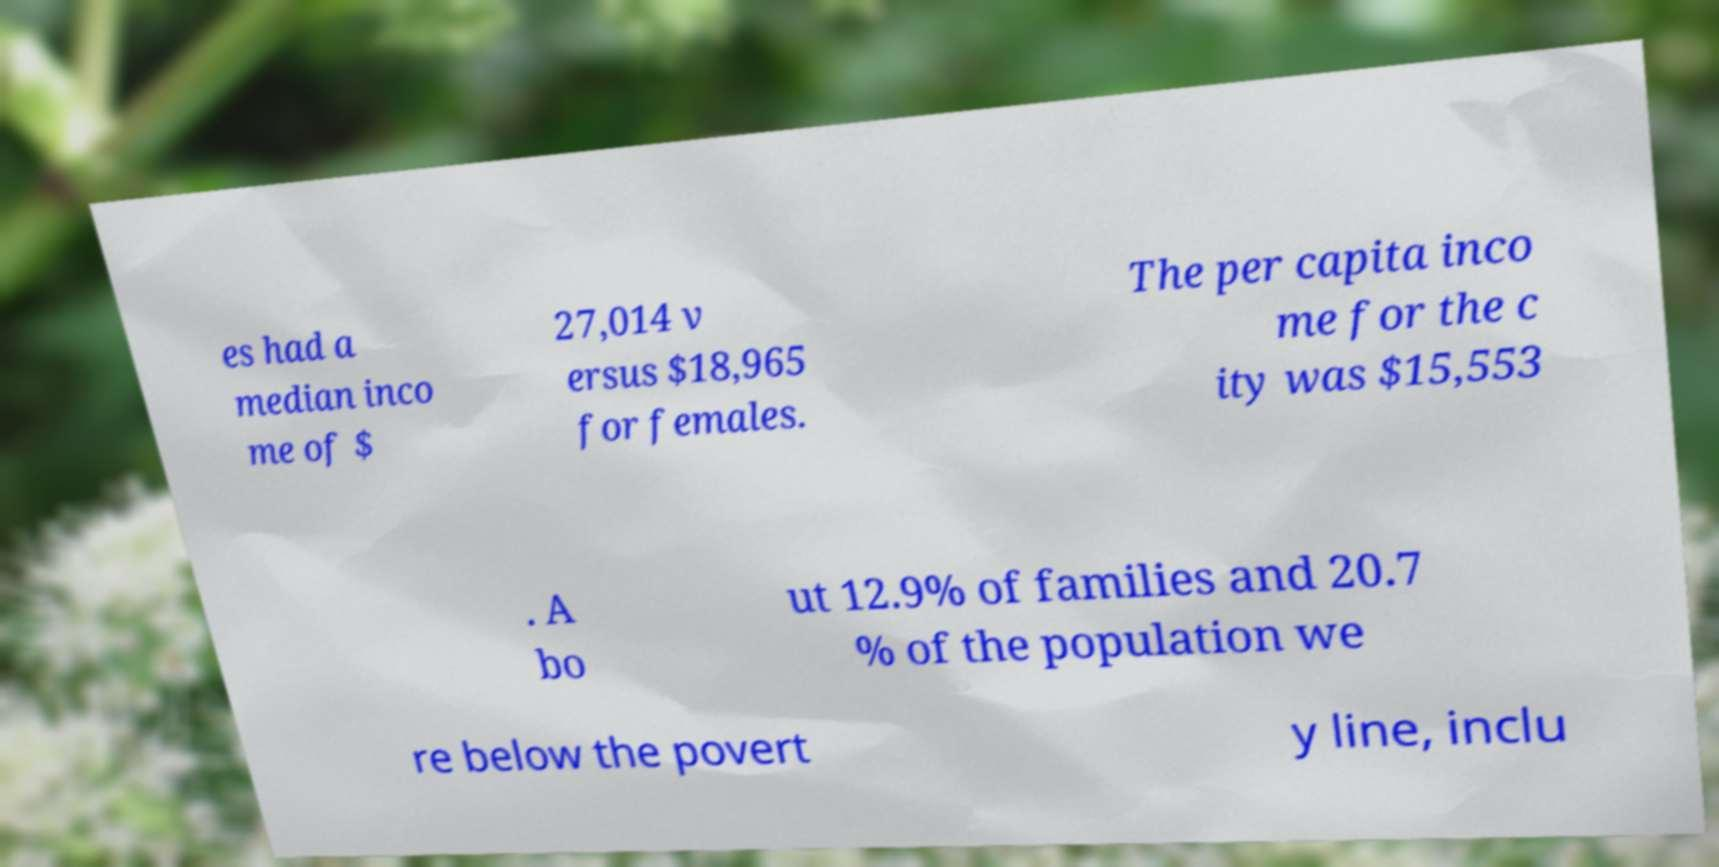There's text embedded in this image that I need extracted. Can you transcribe it verbatim? es had a median inco me of $ 27,014 v ersus $18,965 for females. The per capita inco me for the c ity was $15,553 . A bo ut 12.9% of families and 20.7 % of the population we re below the povert y line, inclu 